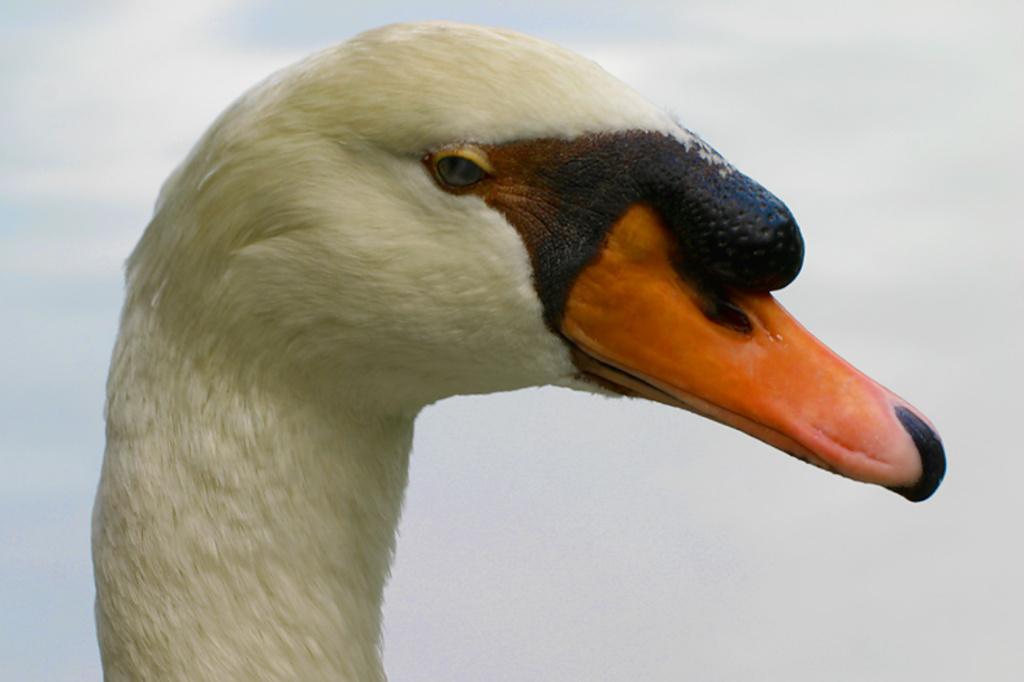Please provide a concise description of this image. In the picture we can see a head part of the duck with orange color beak and some part of it is black in color. 